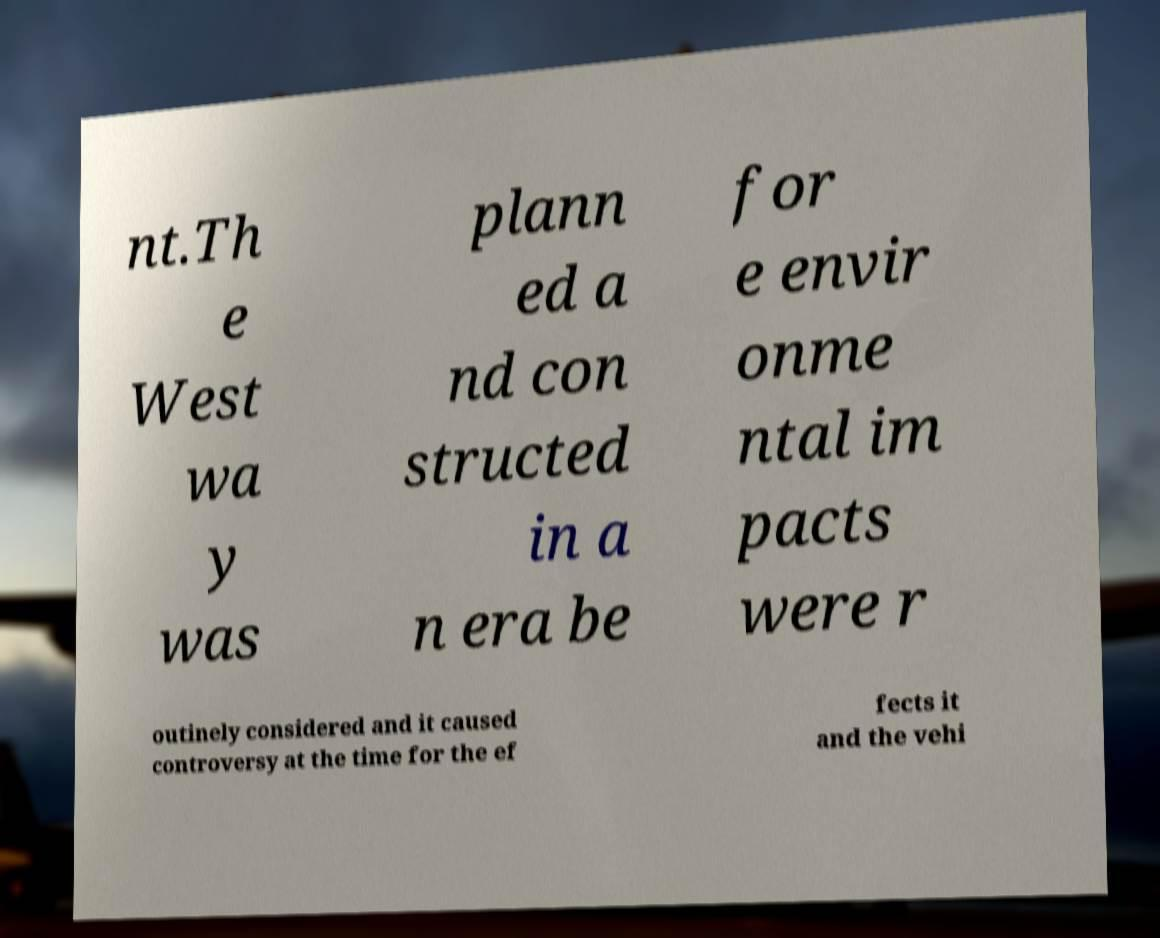I need the written content from this picture converted into text. Can you do that? nt.Th e West wa y was plann ed a nd con structed in a n era be for e envir onme ntal im pacts were r outinely considered and it caused controversy at the time for the ef fects it and the vehi 